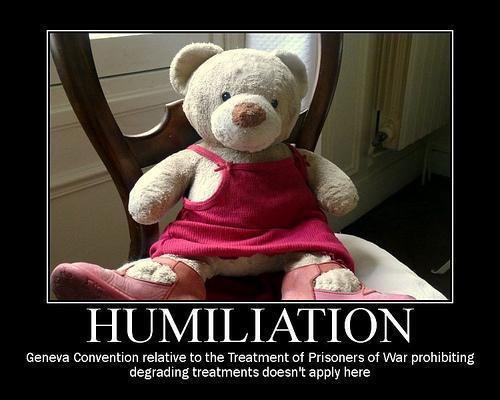How many bears are there?
Give a very brief answer. 1. How many shoes are visible?
Give a very brief answer. 2. How many bears are in the photo?
Give a very brief answer. 1. 